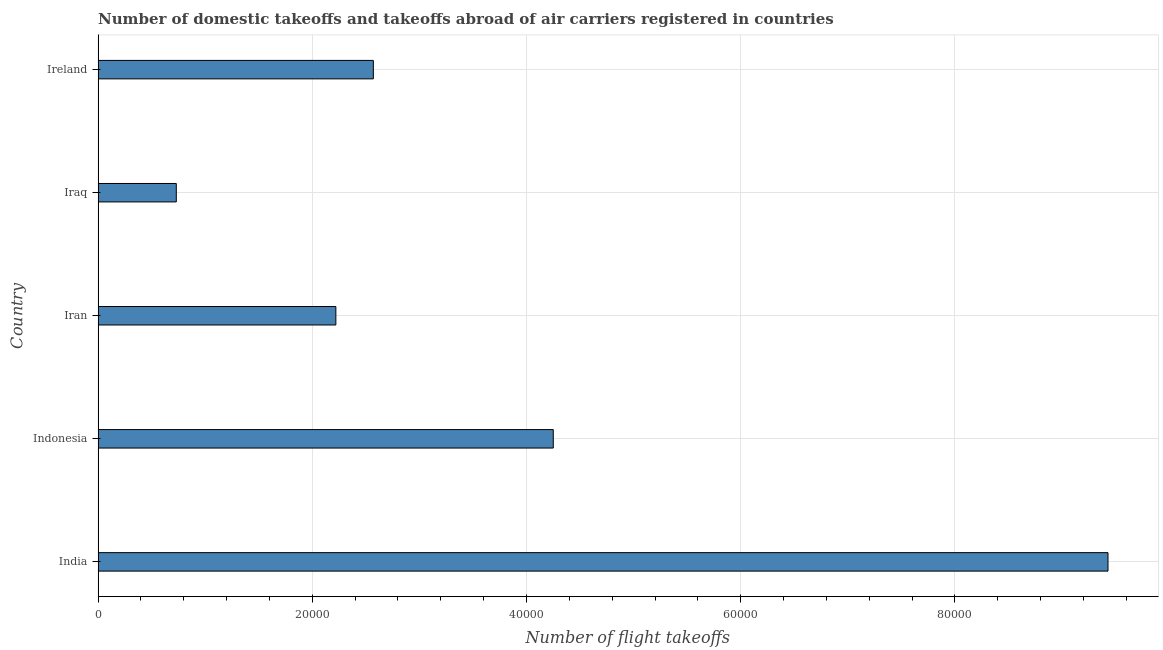Does the graph contain grids?
Offer a very short reply. Yes. What is the title of the graph?
Keep it short and to the point. Number of domestic takeoffs and takeoffs abroad of air carriers registered in countries. What is the label or title of the X-axis?
Your answer should be compact. Number of flight takeoffs. What is the label or title of the Y-axis?
Your answer should be compact. Country. What is the number of flight takeoffs in India?
Provide a succinct answer. 9.43e+04. Across all countries, what is the maximum number of flight takeoffs?
Your response must be concise. 9.43e+04. Across all countries, what is the minimum number of flight takeoffs?
Provide a short and direct response. 7300. In which country was the number of flight takeoffs maximum?
Offer a terse response. India. In which country was the number of flight takeoffs minimum?
Give a very brief answer. Iraq. What is the sum of the number of flight takeoffs?
Your answer should be very brief. 1.92e+05. What is the difference between the number of flight takeoffs in Iraq and Ireland?
Give a very brief answer. -1.84e+04. What is the average number of flight takeoffs per country?
Make the answer very short. 3.84e+04. What is the median number of flight takeoffs?
Your answer should be compact. 2.57e+04. What is the ratio of the number of flight takeoffs in Indonesia to that in Iraq?
Offer a very short reply. 5.82. Is the number of flight takeoffs in India less than that in Indonesia?
Give a very brief answer. No. Is the difference between the number of flight takeoffs in India and Iran greater than the difference between any two countries?
Keep it short and to the point. No. What is the difference between the highest and the second highest number of flight takeoffs?
Offer a terse response. 5.18e+04. Is the sum of the number of flight takeoffs in Indonesia and Iran greater than the maximum number of flight takeoffs across all countries?
Your response must be concise. No. What is the difference between the highest and the lowest number of flight takeoffs?
Give a very brief answer. 8.70e+04. In how many countries, is the number of flight takeoffs greater than the average number of flight takeoffs taken over all countries?
Your response must be concise. 2. Are all the bars in the graph horizontal?
Your response must be concise. Yes. Are the values on the major ticks of X-axis written in scientific E-notation?
Offer a terse response. No. What is the Number of flight takeoffs in India?
Offer a very short reply. 9.43e+04. What is the Number of flight takeoffs in Indonesia?
Give a very brief answer. 4.25e+04. What is the Number of flight takeoffs of Iran?
Your response must be concise. 2.22e+04. What is the Number of flight takeoffs of Iraq?
Make the answer very short. 7300. What is the Number of flight takeoffs in Ireland?
Your response must be concise. 2.57e+04. What is the difference between the Number of flight takeoffs in India and Indonesia?
Offer a very short reply. 5.18e+04. What is the difference between the Number of flight takeoffs in India and Iran?
Provide a short and direct response. 7.21e+04. What is the difference between the Number of flight takeoffs in India and Iraq?
Offer a very short reply. 8.70e+04. What is the difference between the Number of flight takeoffs in India and Ireland?
Ensure brevity in your answer.  6.86e+04. What is the difference between the Number of flight takeoffs in Indonesia and Iran?
Provide a short and direct response. 2.03e+04. What is the difference between the Number of flight takeoffs in Indonesia and Iraq?
Ensure brevity in your answer.  3.52e+04. What is the difference between the Number of flight takeoffs in Indonesia and Ireland?
Your answer should be very brief. 1.68e+04. What is the difference between the Number of flight takeoffs in Iran and Iraq?
Make the answer very short. 1.49e+04. What is the difference between the Number of flight takeoffs in Iran and Ireland?
Offer a very short reply. -3500. What is the difference between the Number of flight takeoffs in Iraq and Ireland?
Provide a succinct answer. -1.84e+04. What is the ratio of the Number of flight takeoffs in India to that in Indonesia?
Your answer should be very brief. 2.22. What is the ratio of the Number of flight takeoffs in India to that in Iran?
Ensure brevity in your answer.  4.25. What is the ratio of the Number of flight takeoffs in India to that in Iraq?
Ensure brevity in your answer.  12.92. What is the ratio of the Number of flight takeoffs in India to that in Ireland?
Your answer should be very brief. 3.67. What is the ratio of the Number of flight takeoffs in Indonesia to that in Iran?
Give a very brief answer. 1.91. What is the ratio of the Number of flight takeoffs in Indonesia to that in Iraq?
Provide a succinct answer. 5.82. What is the ratio of the Number of flight takeoffs in Indonesia to that in Ireland?
Offer a very short reply. 1.65. What is the ratio of the Number of flight takeoffs in Iran to that in Iraq?
Keep it short and to the point. 3.04. What is the ratio of the Number of flight takeoffs in Iran to that in Ireland?
Your answer should be very brief. 0.86. What is the ratio of the Number of flight takeoffs in Iraq to that in Ireland?
Provide a succinct answer. 0.28. 